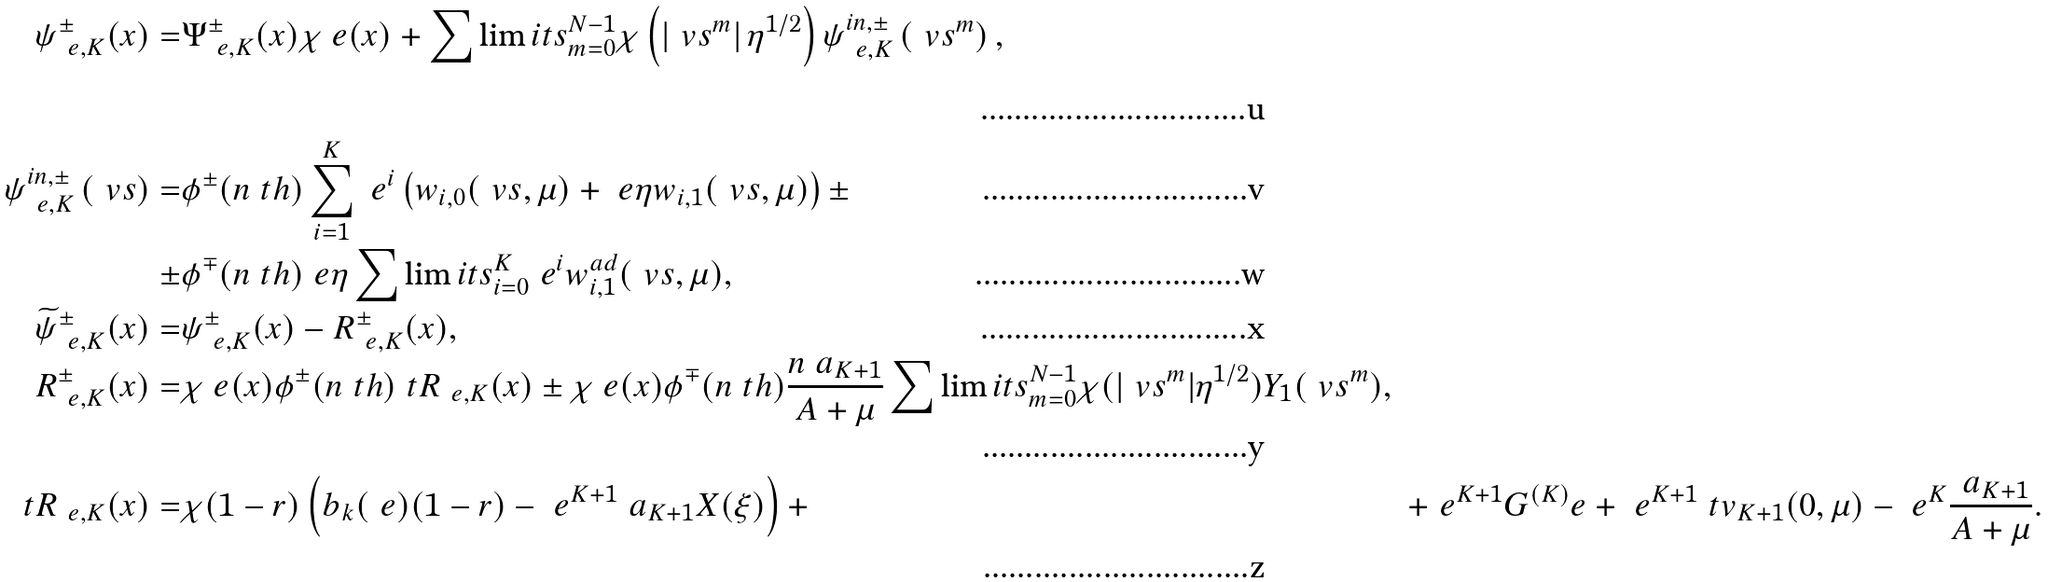<formula> <loc_0><loc_0><loc_500><loc_500>\psi _ { \ e , K } ^ { \pm } ( x ) = & \Psi _ { \ e , K } ^ { \pm } ( x ) \chi _ { \ } e ( x ) + \sum \lim i t s _ { m = 0 } ^ { N - 1 } \chi \left ( \left | \ v s ^ { m } \right | \eta ^ { 1 / 2 } \right ) \psi ^ { i n , \pm } _ { \ e , K } \left ( \ v s ^ { m } \right ) , \\ \psi ^ { i n , \pm } _ { \ e , K } \left ( \ v s \right ) = & \phi ^ { \pm } ( n \ t h ) \sum _ { i = 1 } ^ { K } \ e ^ { i } \left ( w _ { i , 0 } ( \ v s , \mu ) + \ e \eta w _ { i , 1 } ( \ v s , \mu ) \right ) \pm \\ \pm & \phi ^ { \mp } ( n \ t h ) \ e \eta \sum \lim i t s _ { i = 0 } ^ { K } \ e ^ { i } w _ { i , 1 } ^ { a d } ( \ v s , \mu ) , \\ \widetilde { \psi } _ { \ e , K } ^ { \pm } ( x ) = & \psi _ { \ e , K } ^ { \pm } ( x ) - R ^ { \pm } _ { \ e , K } ( x ) , \\ R ^ { \pm } _ { \ e , K } ( x ) = & \chi _ { \ } e ( x ) \phi ^ { \pm } ( n \ t h ) \ t R _ { \ e , K } ( x ) \pm \chi _ { \ } e ( x ) \phi ^ { \mp } ( n \ t h ) \frac { n \ a _ { K + 1 } } { A + \mu } \sum \lim i t s _ { m = 0 } ^ { N - 1 } \chi ( | \ v s ^ { m } | \eta ^ { 1 / 2 } ) Y _ { 1 } ( \ v s ^ { m } ) , \\ \ t R _ { \ e , K } ( x ) = & \chi ( 1 - r ) \left ( b _ { k } ( \ e ) ( 1 - r ) - \ e ^ { K + 1 } \ a _ { K + 1 } X ( \xi ) \right ) + & + \ e ^ { K + 1 } G ^ { ( K ) } _ { \ } e + \ e ^ { K + 1 } \ t v _ { K + 1 } ( 0 , \mu ) - \ e ^ { K } \frac { \ a _ { K + 1 } } { A + \mu } .</formula> 